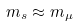Convert formula to latex. <formula><loc_0><loc_0><loc_500><loc_500>m _ { s } \approx m _ { \mu }</formula> 